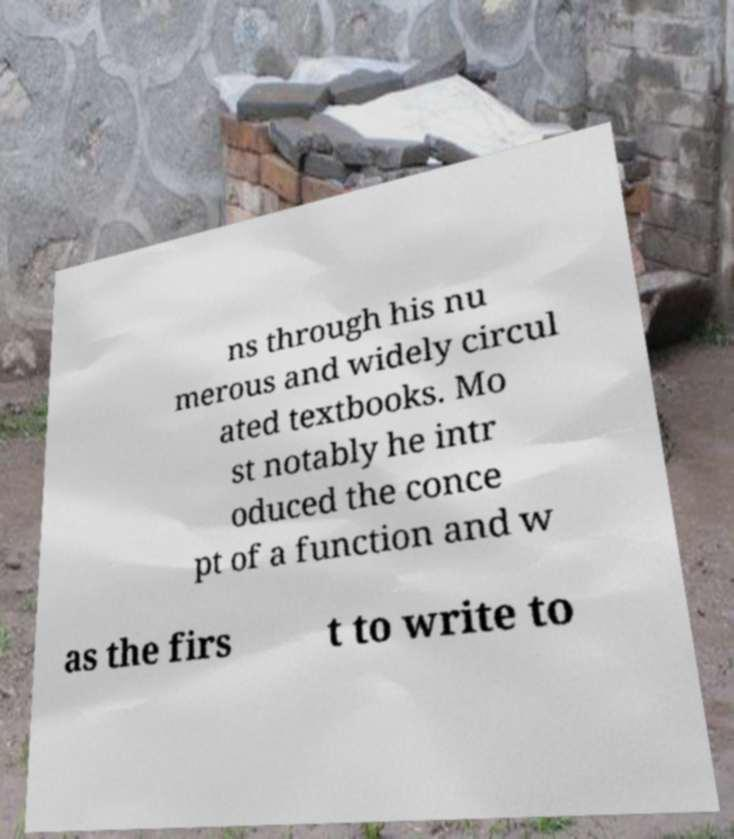Could you extract and type out the text from this image? ns through his nu merous and widely circul ated textbooks. Mo st notably he intr oduced the conce pt of a function and w as the firs t to write to 